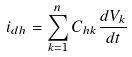<formula> <loc_0><loc_0><loc_500><loc_500>i _ { d h } = \sum _ { k = 1 } ^ { n } C _ { h k } \frac { d V _ { k } } { d t }</formula> 